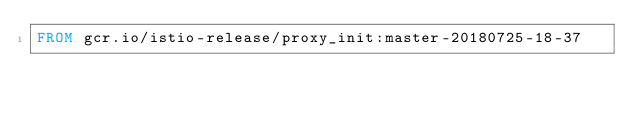<code> <loc_0><loc_0><loc_500><loc_500><_Dockerfile_>FROM gcr.io/istio-release/proxy_init:master-20180725-18-37
</code> 